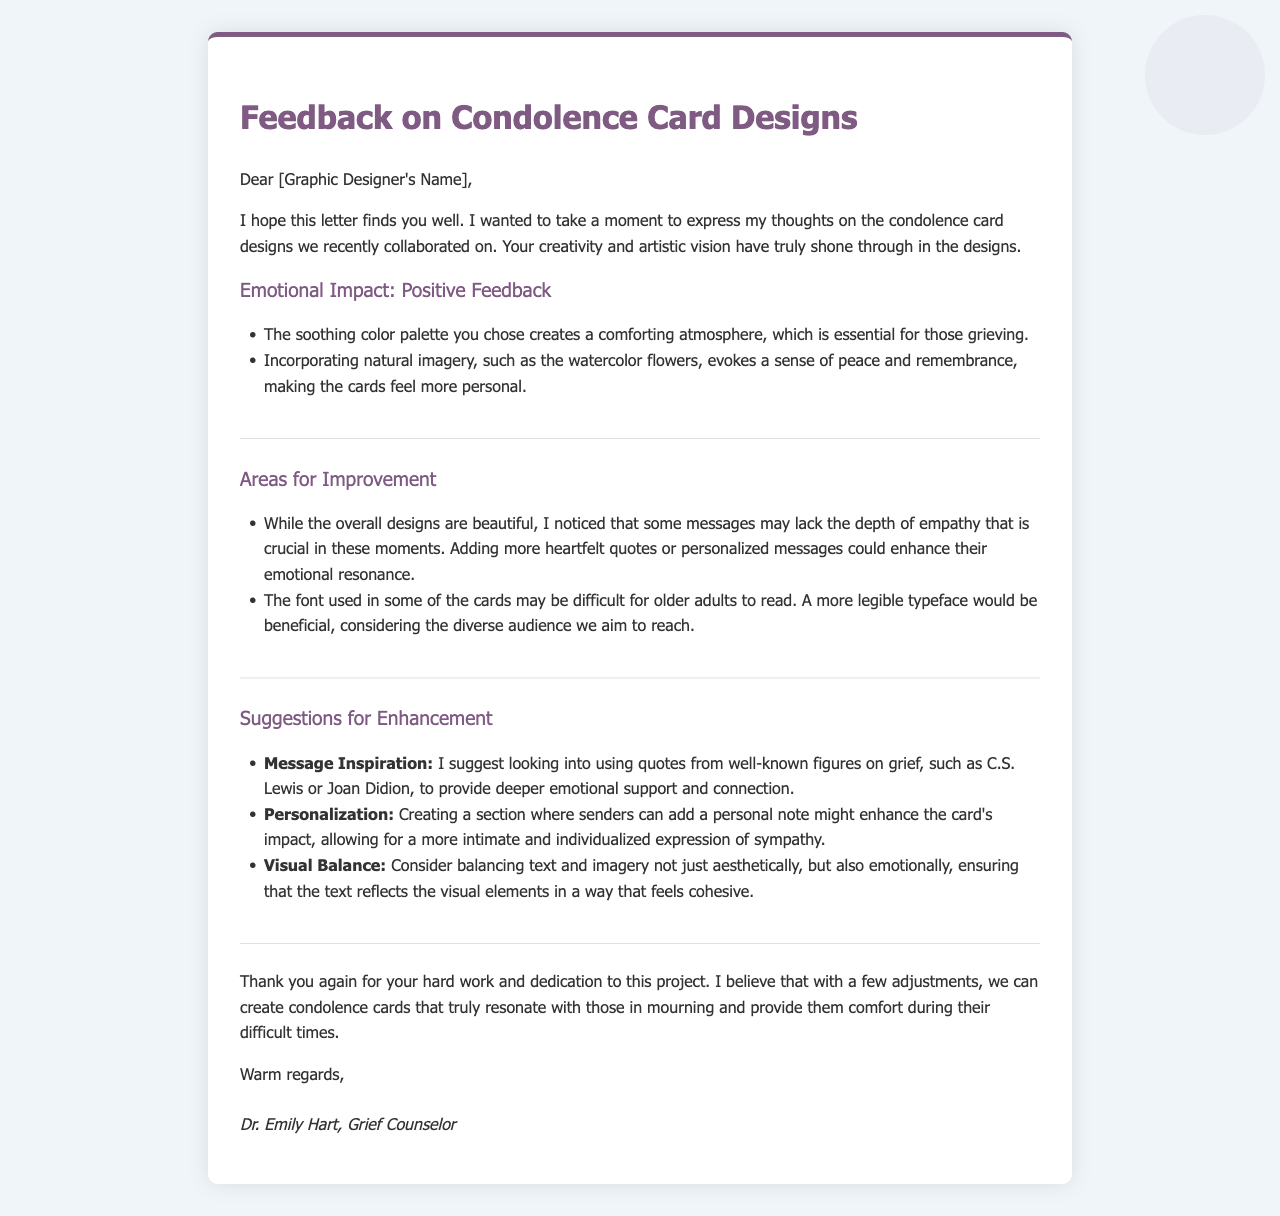What is the name of the grief counselor? The name of the grief counselor is mentioned at the end of the letter.
Answer: Dr. Emily Hart What color palette is mentioned as soothing? The letter references the color palette that creates a comforting atmosphere for those grieving.
Answer: Soothing color palette What type of imagery is incorporated in the designs? Natural imagery, specifically mentioned in the context of evoking peace and remembrance.
Answer: Watercolor flowers What is suggested to enhance the emotional resonance of the messages? The letter states that adding more heartfelt quotes or personalized messages could enhance this aspect.
Answer: More heartfelt quotes Who are the figures suggested for quotes on grief? The letter suggests looking into quotes from well-known figures to provide emotional support.
Answer: C.S. Lewis or Joan Didion What is one of the areas for improvement regarding the font? The letter mentions that the font may be difficult for a specific demographic to read.
Answer: Older adults What is Dr. Hart's profession? The letter includes the title of the person providing feedback at the end.
Answer: Grief Counselor What is one of the suggestions for personalization? One suggestion in the letter mentions creating a section for a specific type of note from the sender.
Answer: Personal note What is the emotional goal of the condolence cards according to the counselor? The counselor emphasizes the importance of the cards during a specific situation for the recipients.
Answer: Provide comfort during mourning 